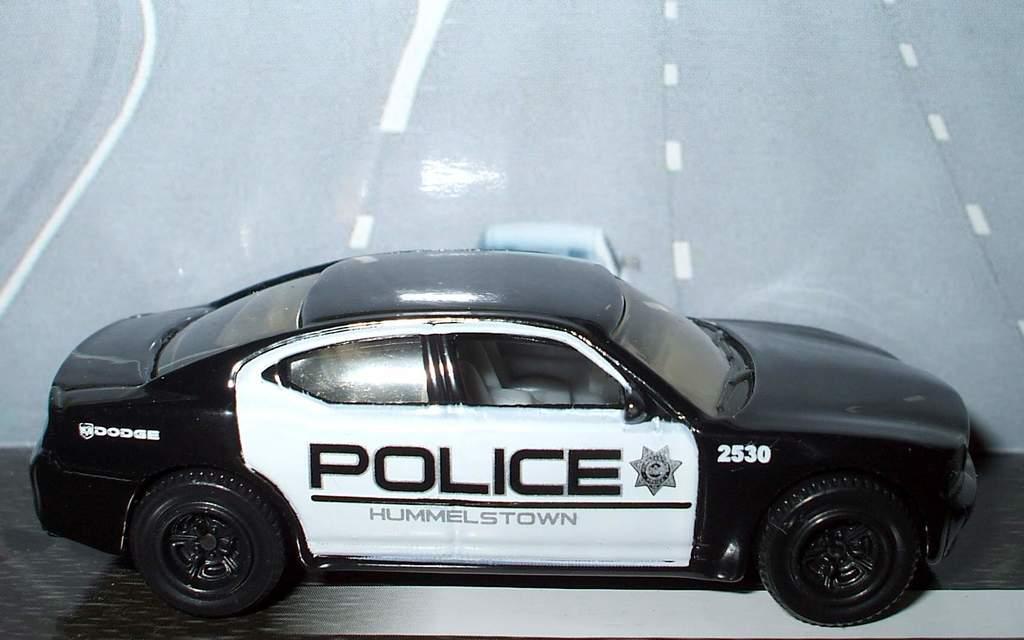Please provide a concise description of this image. This picture shows a toy police car on the table. 